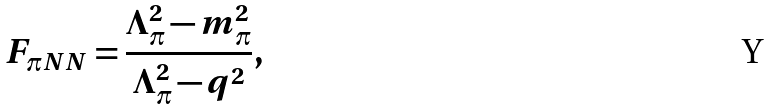Convert formula to latex. <formula><loc_0><loc_0><loc_500><loc_500>F _ { \pi N N } = \frac { \Lambda _ { \pi } ^ { 2 } - m _ { \pi } ^ { 2 } } { \Lambda _ { \pi } ^ { 2 } - q ^ { 2 } } ,</formula> 